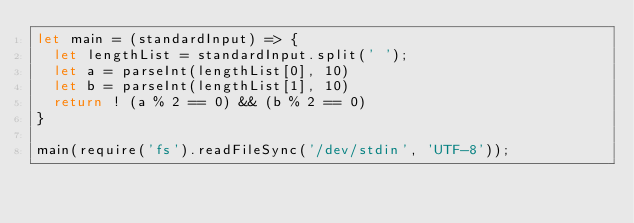Convert code to text. <code><loc_0><loc_0><loc_500><loc_500><_JavaScript_>let main = (standardInput) => {
  let lengthList = standardInput.split(' ');
  let a = parseInt(lengthList[0], 10)
  let b = parseInt(lengthList[1], 10)
  return ! (a % 2 == 0) && (b % 2 == 0)
}

main(require('fs').readFileSync('/dev/stdin', 'UTF-8'));
</code> 